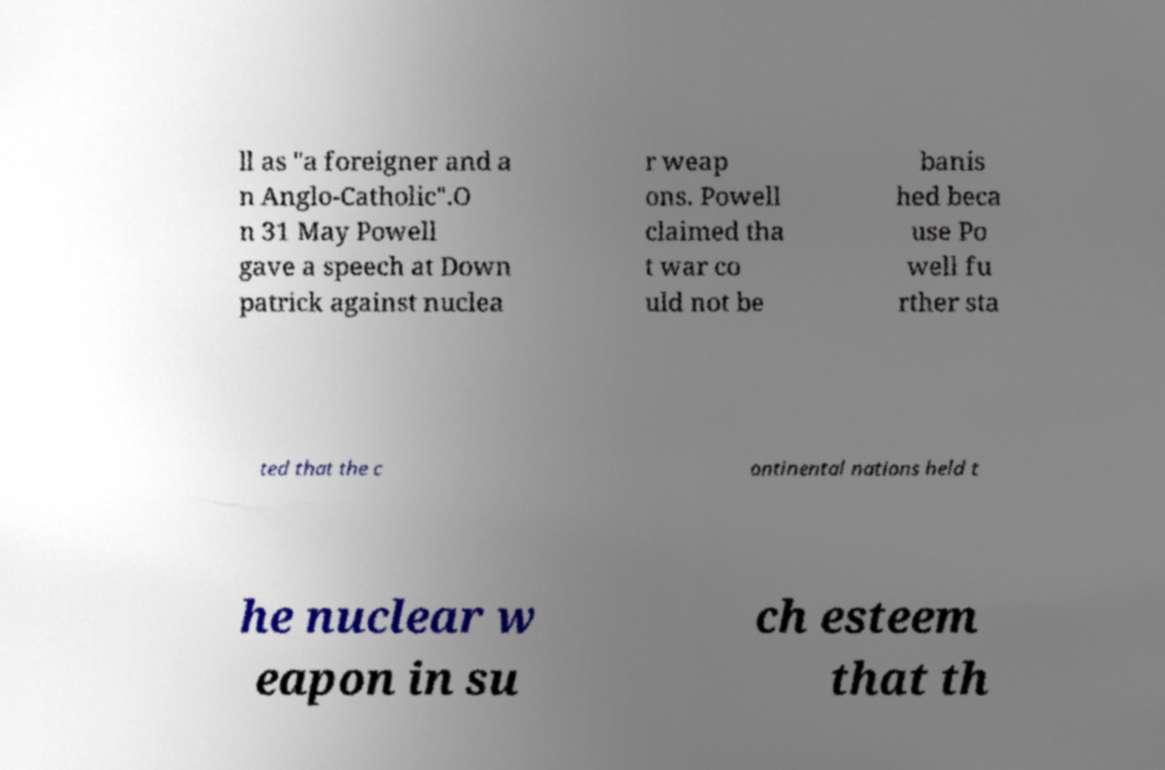Can you accurately transcribe the text from the provided image for me? ll as "a foreigner and a n Anglo-Catholic".O n 31 May Powell gave a speech at Down patrick against nuclea r weap ons. Powell claimed tha t war co uld not be banis hed beca use Po well fu rther sta ted that the c ontinental nations held t he nuclear w eapon in su ch esteem that th 